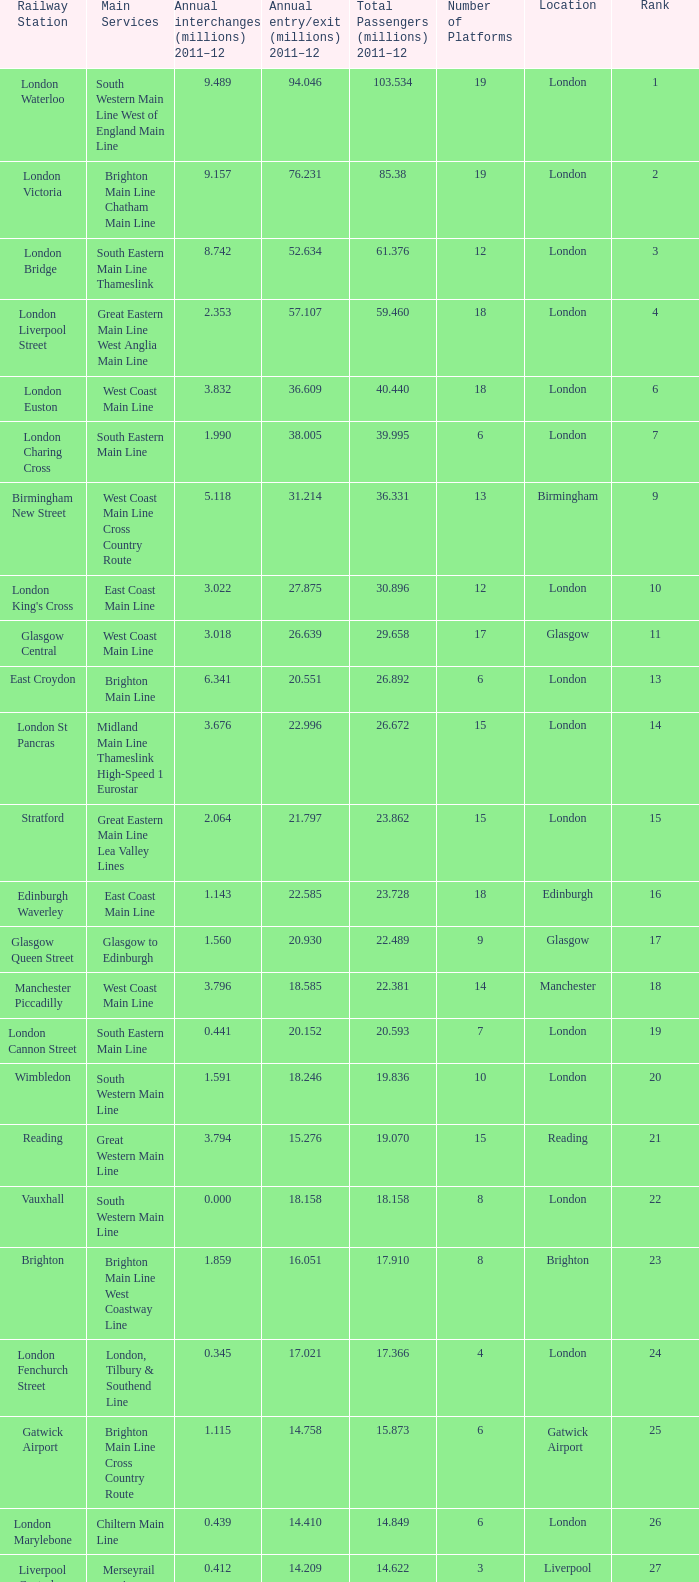What is the main service for the station with 14.849 million passengers 2011-12?  Chiltern Main Line. 